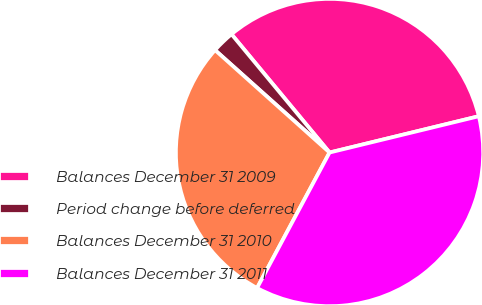Convert chart. <chart><loc_0><loc_0><loc_500><loc_500><pie_chart><fcel>Balances December 31 2009<fcel>Period change before deferred<fcel>Balances December 31 2010<fcel>Balances December 31 2011<nl><fcel>32.22%<fcel>2.37%<fcel>28.8%<fcel>36.62%<nl></chart> 